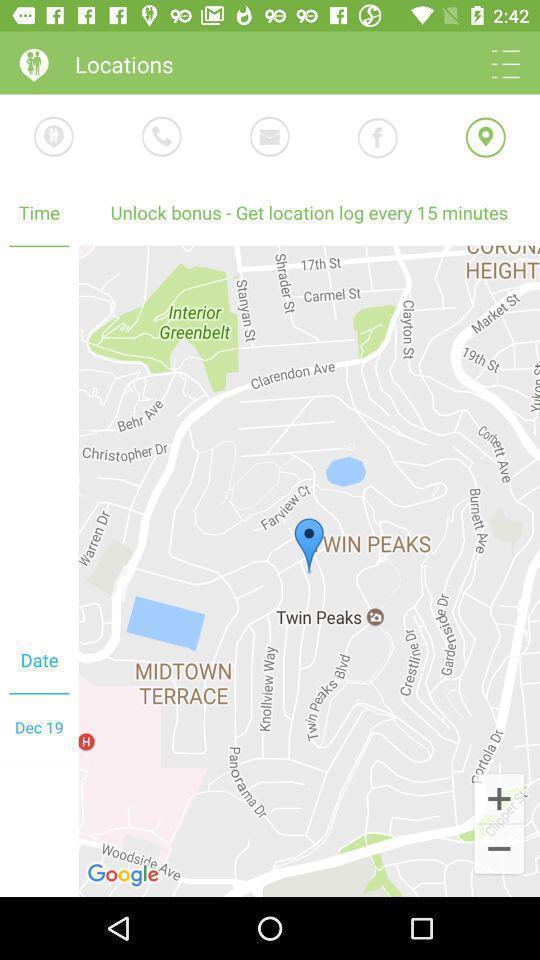What details can you identify in this image? Page with different options in the relationship app. 